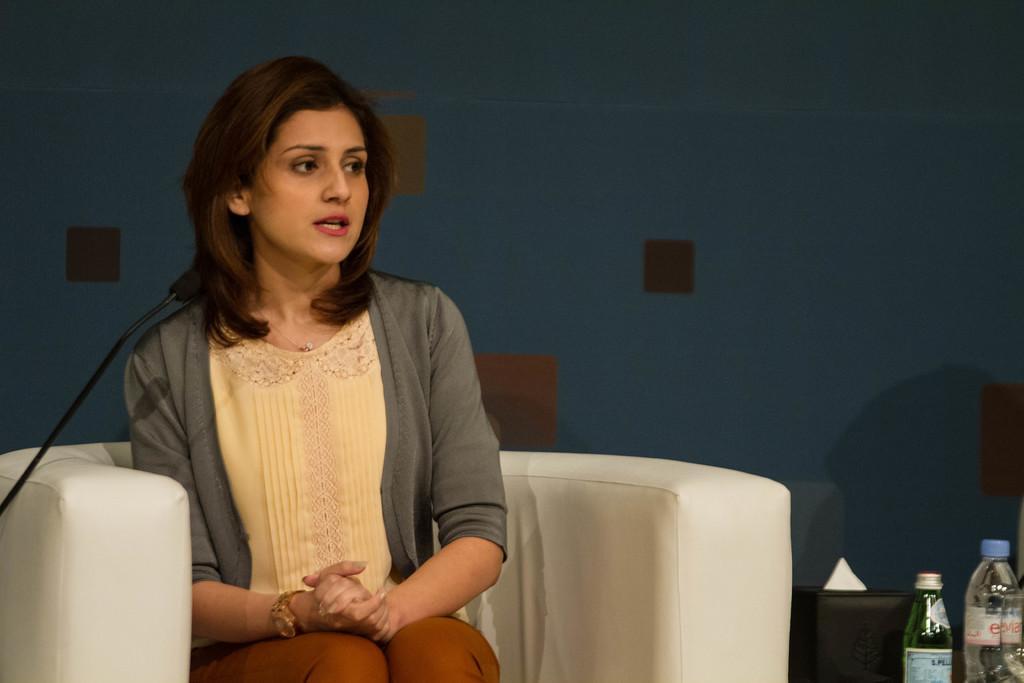How would you summarize this image in a sentence or two? In this image I can see a woman is sitting on a couch. I can see a microphone and few bottles in front of her. I can see the blue and brown colored background. 